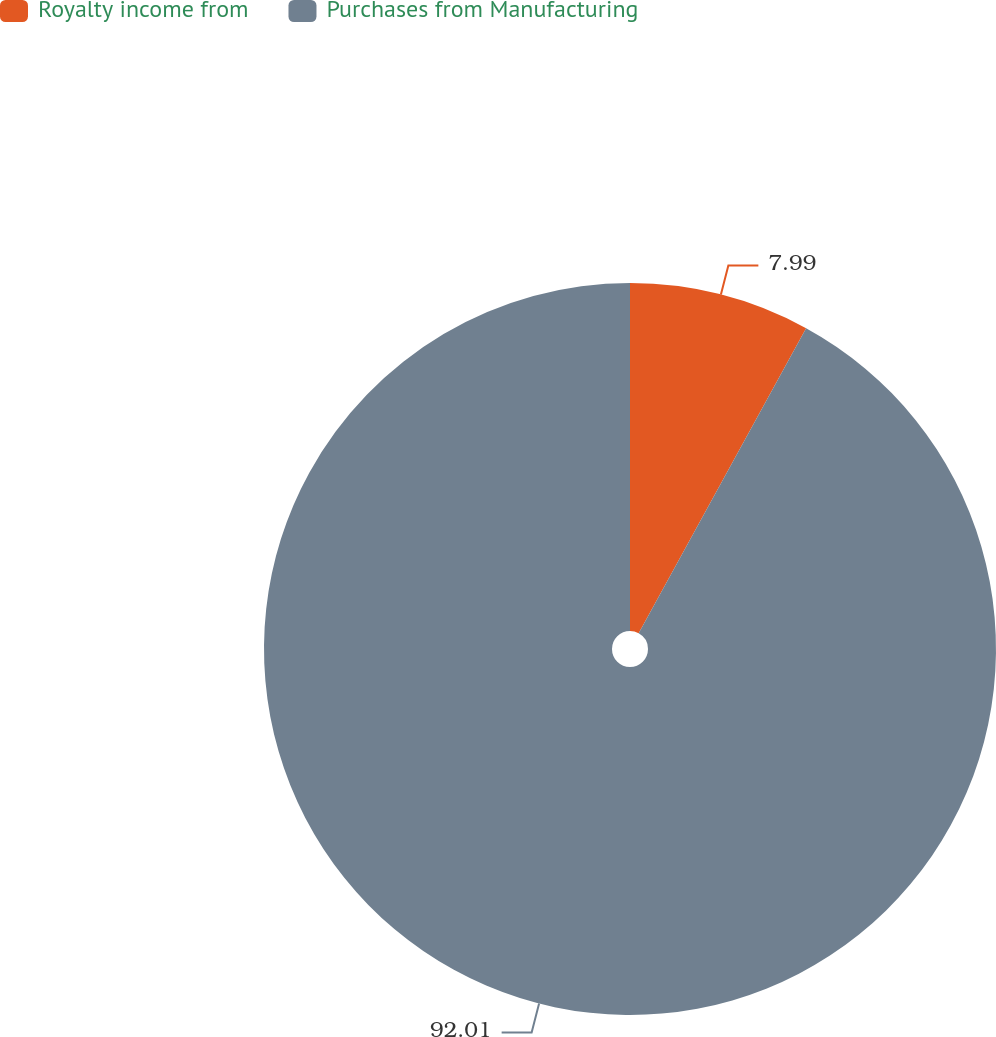Convert chart to OTSL. <chart><loc_0><loc_0><loc_500><loc_500><pie_chart><fcel>Royalty income from<fcel>Purchases from Manufacturing<nl><fcel>7.99%<fcel>92.01%<nl></chart> 